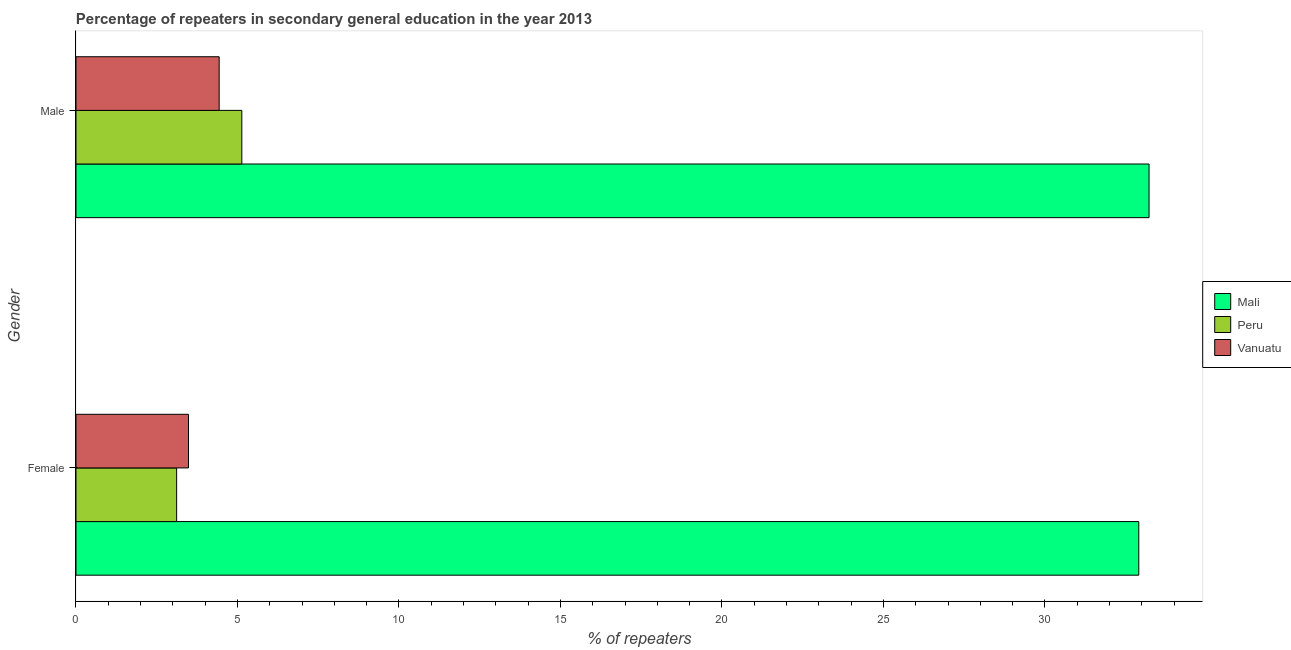How many groups of bars are there?
Offer a very short reply. 2. Are the number of bars on each tick of the Y-axis equal?
Give a very brief answer. Yes. How many bars are there on the 1st tick from the bottom?
Give a very brief answer. 3. What is the percentage of male repeaters in Mali?
Your answer should be very brief. 33.22. Across all countries, what is the maximum percentage of female repeaters?
Offer a very short reply. 32.9. Across all countries, what is the minimum percentage of male repeaters?
Offer a very short reply. 4.43. In which country was the percentage of male repeaters maximum?
Offer a terse response. Mali. In which country was the percentage of male repeaters minimum?
Offer a very short reply. Vanuatu. What is the total percentage of male repeaters in the graph?
Offer a very short reply. 42.79. What is the difference between the percentage of male repeaters in Vanuatu and that in Peru?
Your answer should be compact. -0.7. What is the difference between the percentage of male repeaters in Mali and the percentage of female repeaters in Peru?
Keep it short and to the point. 30.11. What is the average percentage of female repeaters per country?
Provide a short and direct response. 13.17. What is the difference between the percentage of male repeaters and percentage of female repeaters in Vanuatu?
Make the answer very short. 0.95. In how many countries, is the percentage of female repeaters greater than 31 %?
Your response must be concise. 1. What is the ratio of the percentage of male repeaters in Mali to that in Peru?
Make the answer very short. 6.47. Is the percentage of male repeaters in Mali less than that in Vanuatu?
Give a very brief answer. No. In how many countries, is the percentage of female repeaters greater than the average percentage of female repeaters taken over all countries?
Your response must be concise. 1. What does the 3rd bar from the top in Female represents?
Offer a terse response. Mali. What does the 1st bar from the bottom in Female represents?
Your answer should be compact. Mali. How many bars are there?
Ensure brevity in your answer.  6. Are the values on the major ticks of X-axis written in scientific E-notation?
Your answer should be very brief. No. Does the graph contain any zero values?
Give a very brief answer. No. Does the graph contain grids?
Ensure brevity in your answer.  No. Where does the legend appear in the graph?
Your response must be concise. Center right. What is the title of the graph?
Your response must be concise. Percentage of repeaters in secondary general education in the year 2013. Does "Zambia" appear as one of the legend labels in the graph?
Your answer should be compact. No. What is the label or title of the X-axis?
Your response must be concise. % of repeaters. What is the % of repeaters in Mali in Female?
Offer a very short reply. 32.9. What is the % of repeaters of Peru in Female?
Your answer should be compact. 3.12. What is the % of repeaters of Vanuatu in Female?
Provide a succinct answer. 3.48. What is the % of repeaters in Mali in Male?
Offer a terse response. 33.22. What is the % of repeaters of Peru in Male?
Offer a very short reply. 5.13. What is the % of repeaters of Vanuatu in Male?
Ensure brevity in your answer.  4.43. Across all Gender, what is the maximum % of repeaters of Mali?
Keep it short and to the point. 33.22. Across all Gender, what is the maximum % of repeaters in Peru?
Your answer should be very brief. 5.13. Across all Gender, what is the maximum % of repeaters in Vanuatu?
Your response must be concise. 4.43. Across all Gender, what is the minimum % of repeaters in Mali?
Keep it short and to the point. 32.9. Across all Gender, what is the minimum % of repeaters of Peru?
Provide a succinct answer. 3.12. Across all Gender, what is the minimum % of repeaters in Vanuatu?
Give a very brief answer. 3.48. What is the total % of repeaters of Mali in the graph?
Ensure brevity in your answer.  66.13. What is the total % of repeaters in Peru in the graph?
Ensure brevity in your answer.  8.25. What is the total % of repeaters in Vanuatu in the graph?
Your response must be concise. 7.92. What is the difference between the % of repeaters in Mali in Female and that in Male?
Ensure brevity in your answer.  -0.32. What is the difference between the % of repeaters in Peru in Female and that in Male?
Offer a very short reply. -2.02. What is the difference between the % of repeaters of Vanuatu in Female and that in Male?
Provide a short and direct response. -0.95. What is the difference between the % of repeaters of Mali in Female and the % of repeaters of Peru in Male?
Your answer should be compact. 27.77. What is the difference between the % of repeaters in Mali in Female and the % of repeaters in Vanuatu in Male?
Offer a very short reply. 28.47. What is the difference between the % of repeaters of Peru in Female and the % of repeaters of Vanuatu in Male?
Your answer should be very brief. -1.32. What is the average % of repeaters in Mali per Gender?
Ensure brevity in your answer.  33.06. What is the average % of repeaters in Peru per Gender?
Make the answer very short. 4.13. What is the average % of repeaters in Vanuatu per Gender?
Keep it short and to the point. 3.96. What is the difference between the % of repeaters of Mali and % of repeaters of Peru in Female?
Provide a short and direct response. 29.79. What is the difference between the % of repeaters in Mali and % of repeaters in Vanuatu in Female?
Provide a succinct answer. 29.42. What is the difference between the % of repeaters of Peru and % of repeaters of Vanuatu in Female?
Provide a short and direct response. -0.37. What is the difference between the % of repeaters of Mali and % of repeaters of Peru in Male?
Your answer should be compact. 28.09. What is the difference between the % of repeaters of Mali and % of repeaters of Vanuatu in Male?
Your response must be concise. 28.79. What is the difference between the % of repeaters in Peru and % of repeaters in Vanuatu in Male?
Offer a very short reply. 0.7. What is the ratio of the % of repeaters in Peru in Female to that in Male?
Your answer should be very brief. 0.61. What is the ratio of the % of repeaters of Vanuatu in Female to that in Male?
Ensure brevity in your answer.  0.79. What is the difference between the highest and the second highest % of repeaters in Mali?
Keep it short and to the point. 0.32. What is the difference between the highest and the second highest % of repeaters in Peru?
Ensure brevity in your answer.  2.02. What is the difference between the highest and the second highest % of repeaters of Vanuatu?
Your answer should be compact. 0.95. What is the difference between the highest and the lowest % of repeaters in Mali?
Provide a short and direct response. 0.32. What is the difference between the highest and the lowest % of repeaters of Peru?
Keep it short and to the point. 2.02. What is the difference between the highest and the lowest % of repeaters in Vanuatu?
Offer a very short reply. 0.95. 